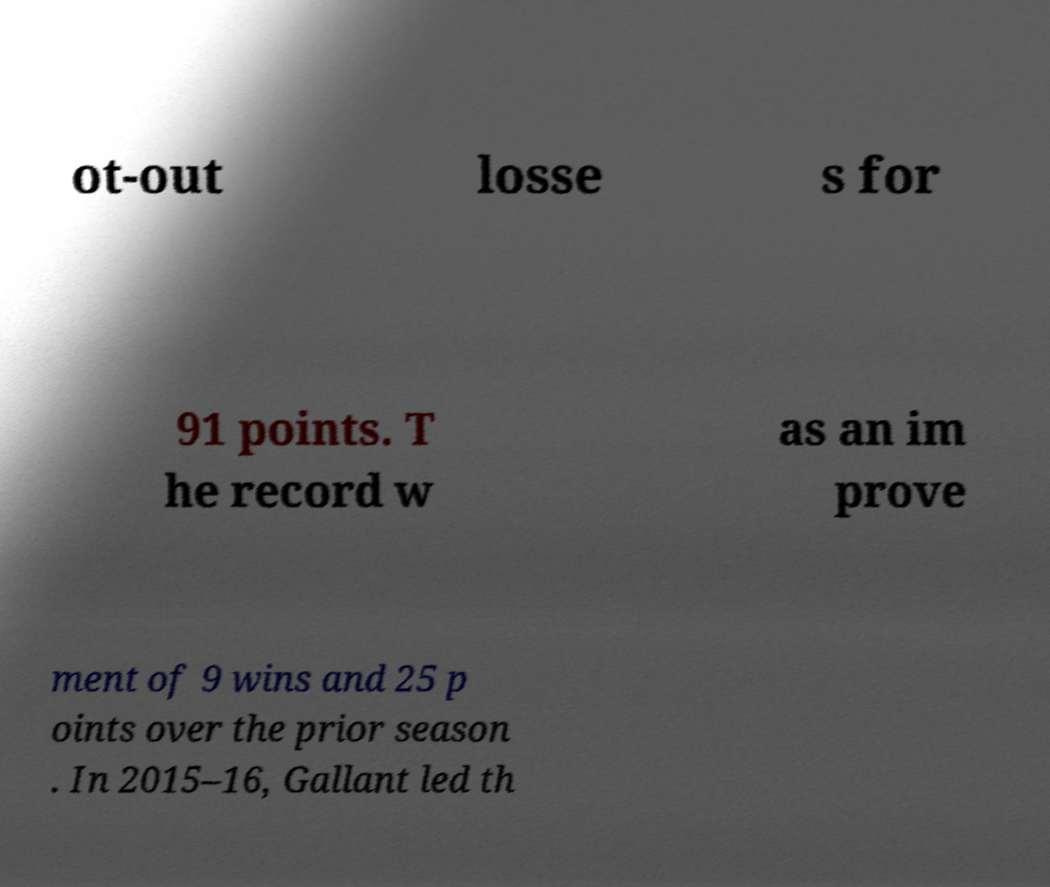Could you assist in decoding the text presented in this image and type it out clearly? ot-out losse s for 91 points. T he record w as an im prove ment of 9 wins and 25 p oints over the prior season . In 2015–16, Gallant led th 